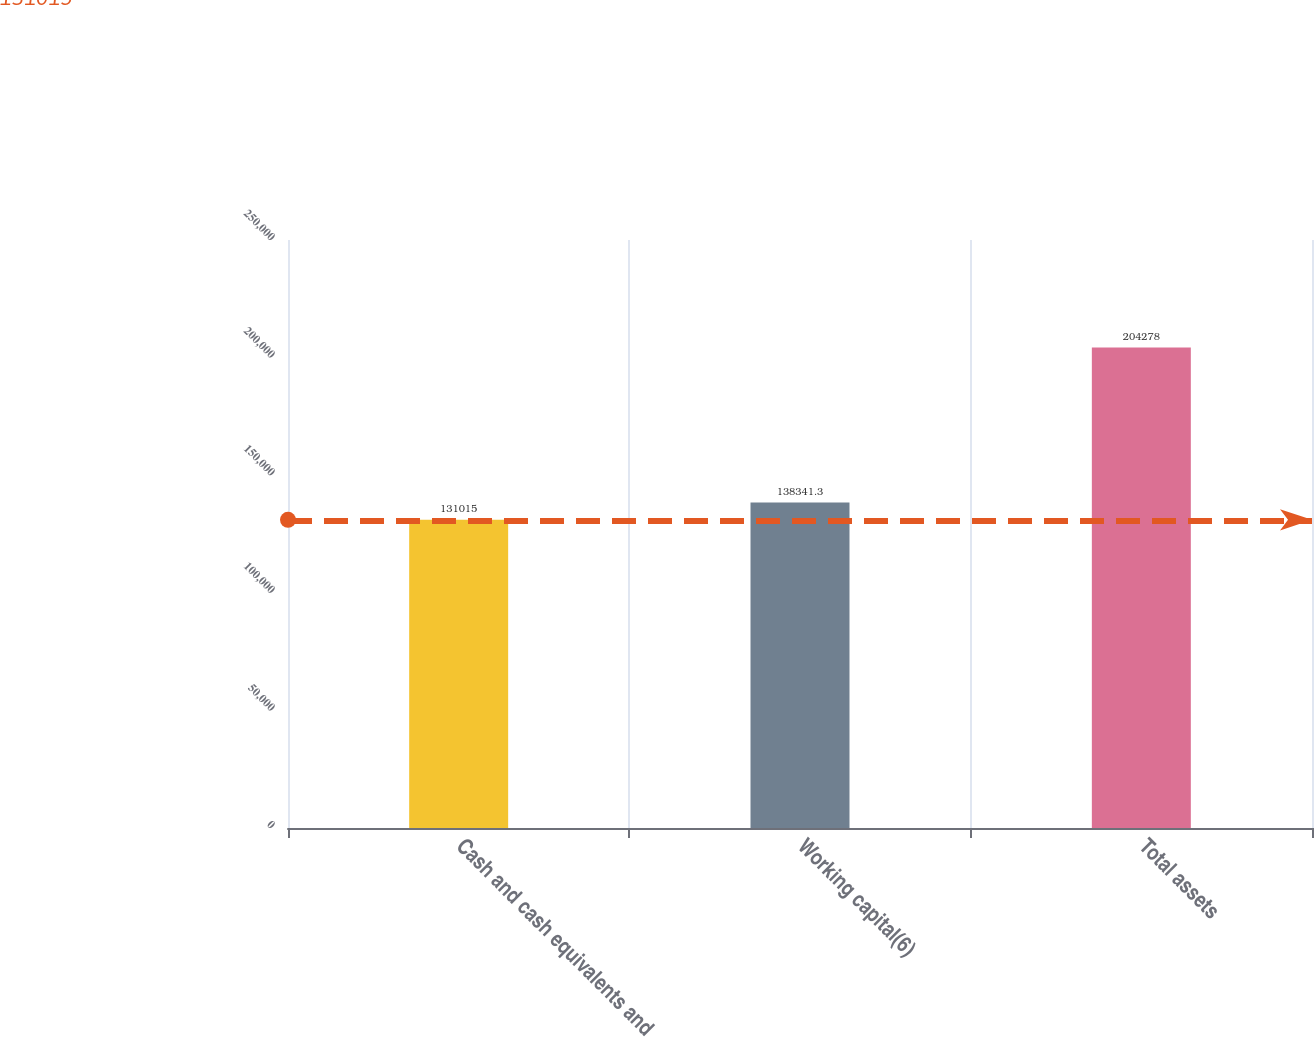Convert chart. <chart><loc_0><loc_0><loc_500><loc_500><bar_chart><fcel>Cash and cash equivalents and<fcel>Working capital(6)<fcel>Total assets<nl><fcel>131015<fcel>138341<fcel>204278<nl></chart> 